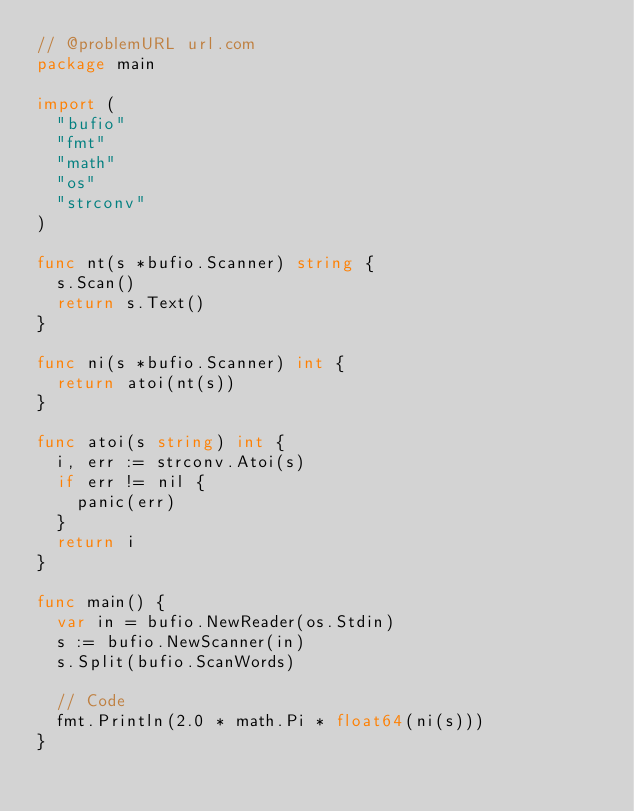Convert code to text. <code><loc_0><loc_0><loc_500><loc_500><_Go_>// @problemURL url.com
package main

import (
	"bufio"
	"fmt"
	"math"
	"os"
	"strconv"
)

func nt(s *bufio.Scanner) string {
	s.Scan()
	return s.Text()
}

func ni(s *bufio.Scanner) int {
	return atoi(nt(s))
}

func atoi(s string) int {
	i, err := strconv.Atoi(s)
	if err != nil {
		panic(err)
	}
	return i
}

func main() {
	var in = bufio.NewReader(os.Stdin)
	s := bufio.NewScanner(in)
	s.Split(bufio.ScanWords)

	// Code
	fmt.Println(2.0 * math.Pi * float64(ni(s)))
}</code> 